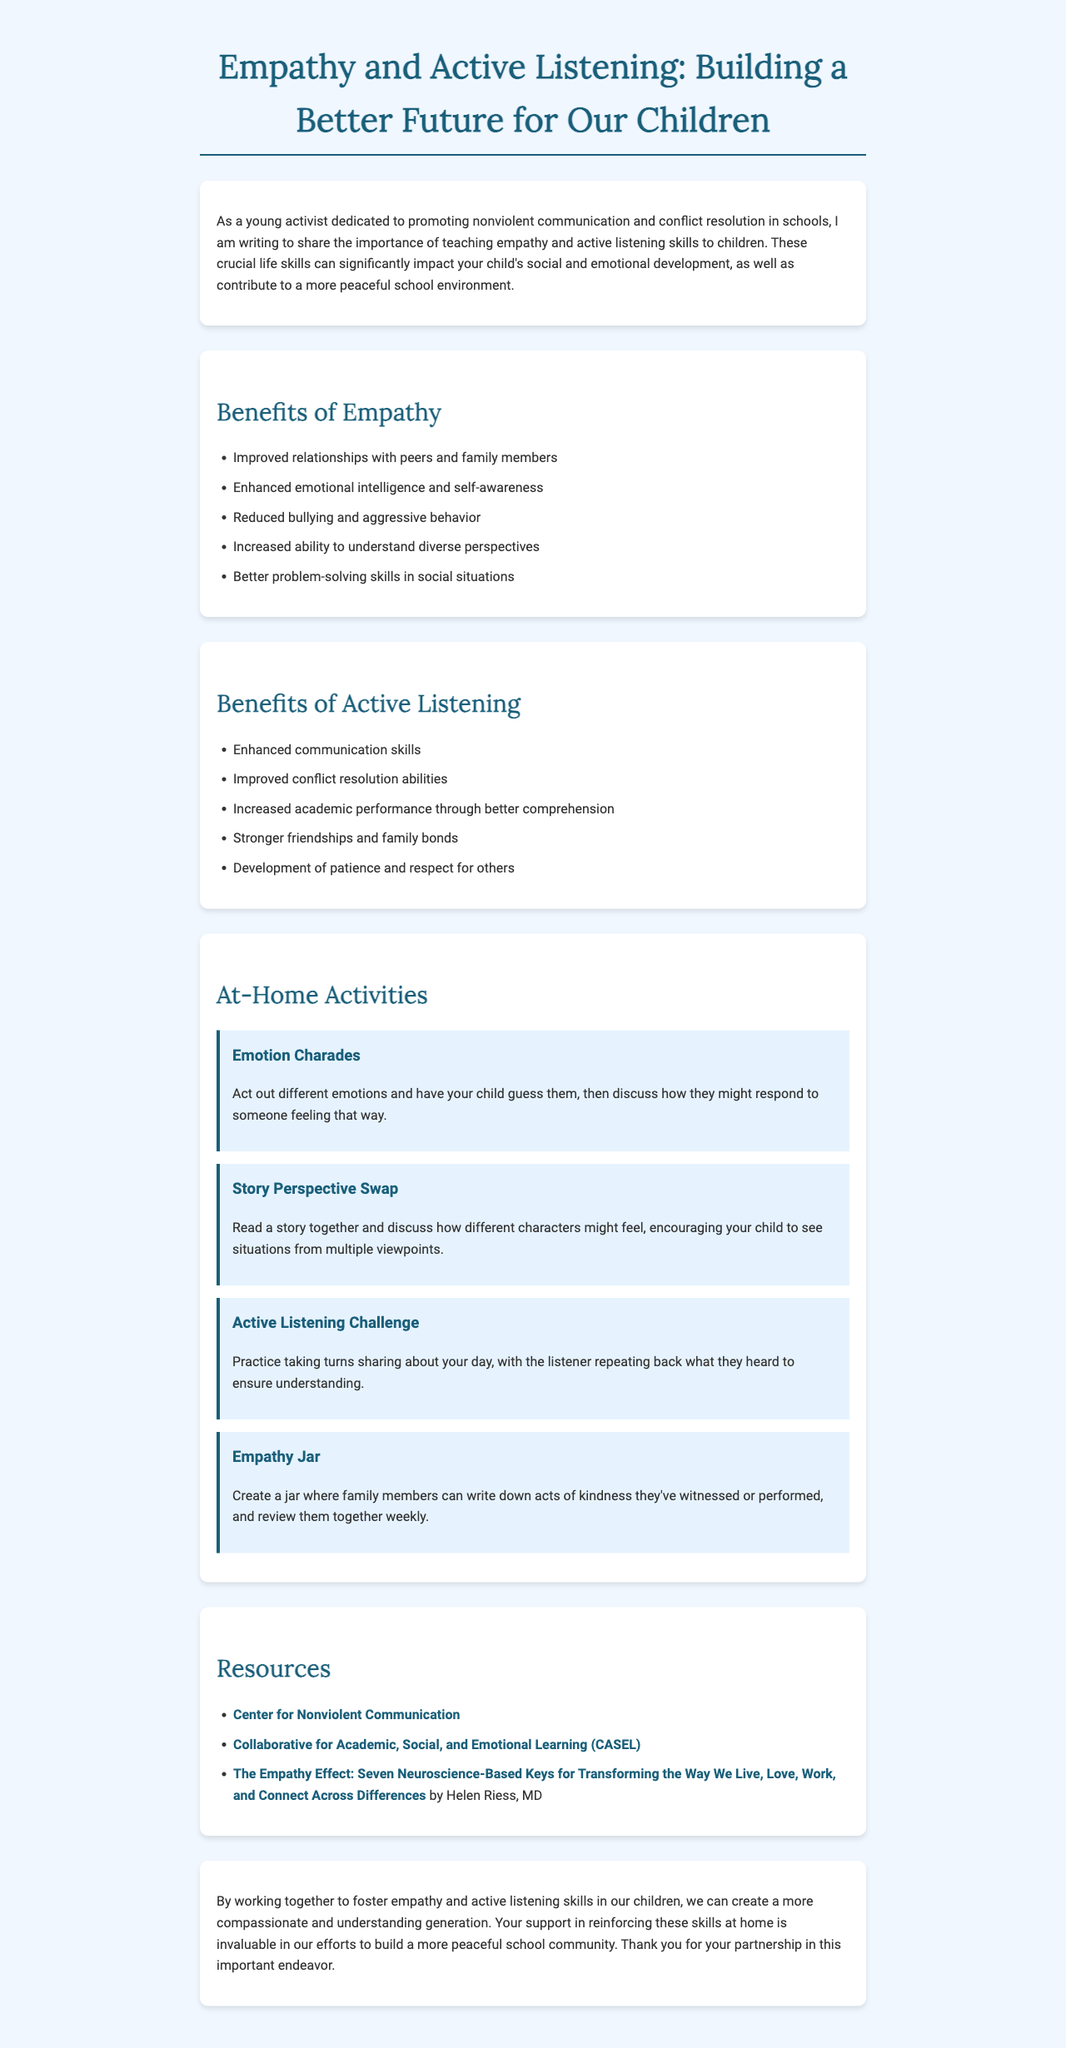What is the main purpose of the letter? The letter aims to share the importance of teaching empathy and active listening skills to children.
Answer: To teach empathy and active listening List two benefits of empathy mentioned in the letter. The document lists several benefits of empathy, including improved relationships and reduced bullying.
Answer: Improved relationships, reduced bullying What activity is suggested for practicing active listening at home? The document provides a specific activity called "Active Listening Challenge" as a way to practice listening skills.
Answer: Active Listening Challenge How many at-home activities are suggested in the letter? The letter lists four specific at-home activities for parents to engage their children in practicing empathy and listening.
Answer: Four Who is the author of "The Empathy Effect"? The letter references a book by a specific author related to the topic of empathy.
Answer: Helen Riess, MD What organization focuses on nonviolent communication according to the letter? The letter mentions an organization that is dedicated to nonviolent communication and provides their website.
Answer: Center for Nonviolent Communication What is the title of the letter? The title of the letter is prominently displayed at the top of the document.
Answer: Empathy and Active Listening: Building a Better Future for Our Children 